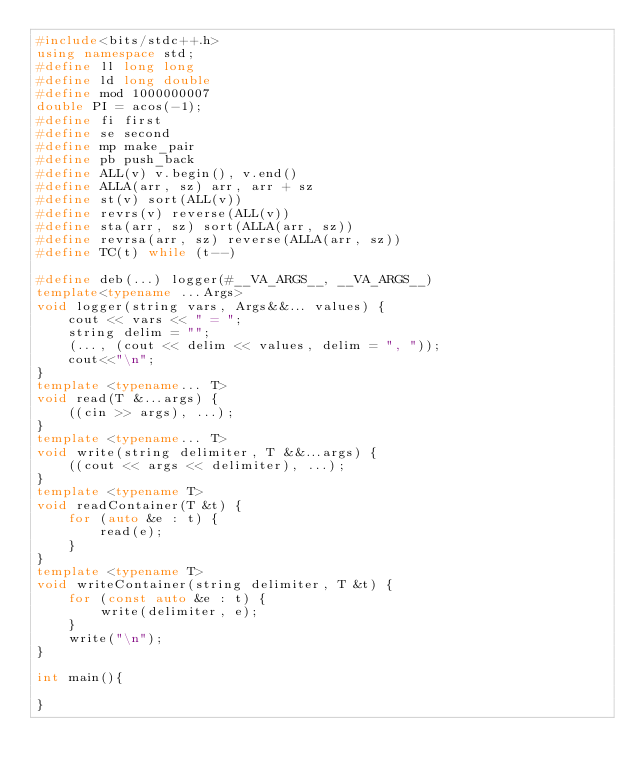Convert code to text. <code><loc_0><loc_0><loc_500><loc_500><_C++_>#include<bits/stdc++.h>
using namespace std;
#define ll long long
#define ld long double
#define mod 1000000007
double PI = acos(-1);
#define fi first
#define se second
#define mp make_pair
#define pb push_back
#define ALL(v) v.begin(), v.end()
#define ALLA(arr, sz) arr, arr + sz
#define st(v) sort(ALL(v))
#define revrs(v) reverse(ALL(v))
#define sta(arr, sz) sort(ALLA(arr, sz))
#define revrsa(arr, sz) reverse(ALLA(arr, sz))
#define TC(t) while (t--)

#define deb(...) logger(#__VA_ARGS__, __VA_ARGS__)
template<typename ...Args>
void logger(string vars, Args&&... values) {
    cout << vars << " = ";
    string delim = "";
    (..., (cout << delim << values, delim = ", "));
    cout<<"\n";
}
template <typename... T>
void read(T &...args) {
    ((cin >> args), ...);
}
template <typename... T>
void write(string delimiter, T &&...args) {
    ((cout << args << delimiter), ...);
}
template <typename T>
void readContainer(T &t) {
    for (auto &e : t) {
        read(e);
    }
}
template <typename T>
void writeContainer(string delimiter, T &t) {
    for (const auto &e : t) {
        write(delimiter, e);
    }
    write("\n");
}

int main(){

}</code> 